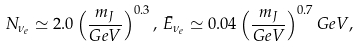Convert formula to latex. <formula><loc_0><loc_0><loc_500><loc_500>N _ { \nu _ { e } } \simeq 2 . 0 \left ( \frac { m _ { J } } { G e V } \right ) ^ { 0 . 3 } , \, \bar { E } _ { \nu _ { e } } \simeq 0 . 0 4 \left ( \frac { m _ { J } } { G e V } \right ) ^ { 0 . 7 } G e V ,</formula> 